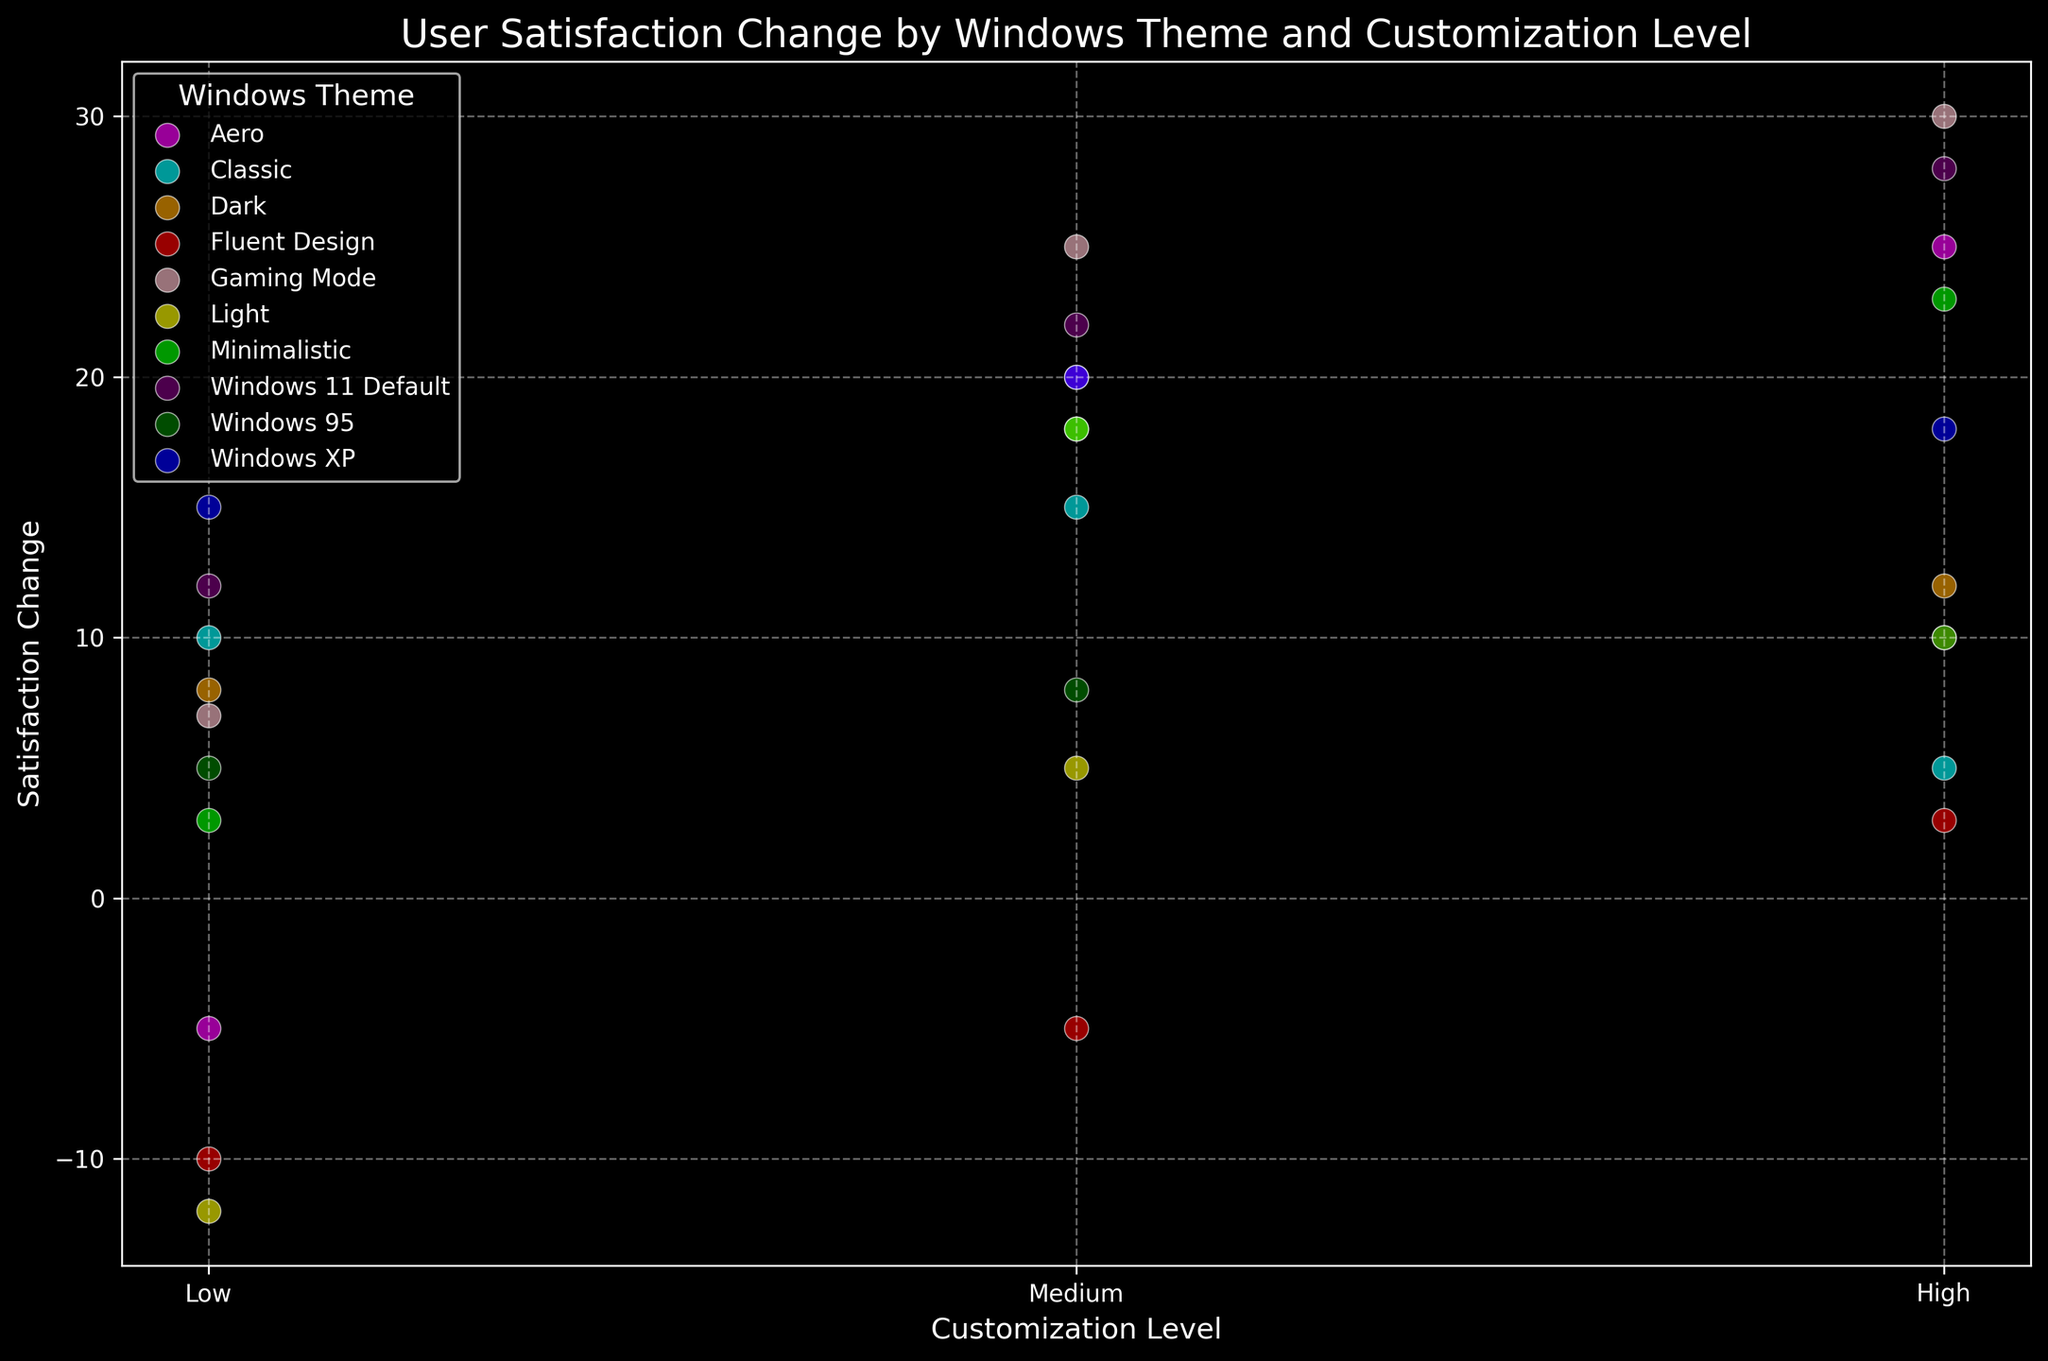What theme has the highest satisfaction change at the highest level of customization? Look at the y-value (satisfaction change) for all themes at the "High" level of customization. The theme with the highest value is "Gaming Mode" with a satisfaction change of 30.
Answer: Gaming Mode Which theme shows a negative satisfaction change at a low level of customization? Identify the points at the "Low" level of customization and check their satisfaction change values. "Aero," "Light," and "Fluent Design" have negative changes, with Aero at -5, Light at -12, and Fluent Design at -10.
Answer: Aero, Light, Fluent Design What is the average satisfaction change for the Classic theme across all customization levels? Sum the satisfaction changes for Classic (10 + 15 + 5 = 30) and divide by the number of levels (3). The average satisfaction change is 30 / 3 = 10.
Answer: 10 Which theme has the smallest range of satisfaction change values across all customization levels? Calculate the range (max - min) of satisfaction change for each theme and identify the smallest. "Fluent Design" ranges from -10 to 3, which is 13, the smallest range among all themes.
Answer: Fluent Design What is the difference in satisfaction change between the highest and lowest levels of customization for the Windows 11 Default theme? Identify satisfaction changes for Windows 11 Default (12 at Low, 22 at Medium, 28 at High). The difference between High (28) and Low (12) is 28 - 12 = 16.
Answer: 16 How many themes show positive satisfaction change at the "Medium" customization level? Count the points at "Medium" customization that have positive values: "Classic," "Aero," "Dark," "Light," "Windows XP," "Windows 95," "Windows 11 Default," "Gaming Mode," and "Minimalistic." There are 9 themes.
Answer: 9 What color represents the Windows XP theme in the plot? Refer to the legend of the plot. Windows XP is represented by the color blue.
Answer: Blue Which themes have a satisfaction change of 20 in "Medium" customization? Check the satisfaction changes for "Medium" customization and identify themes with a value of 20. Both "Aero" and "Windows XP" have a satisfaction change of 20.
Answer: Aero, Windows XP 